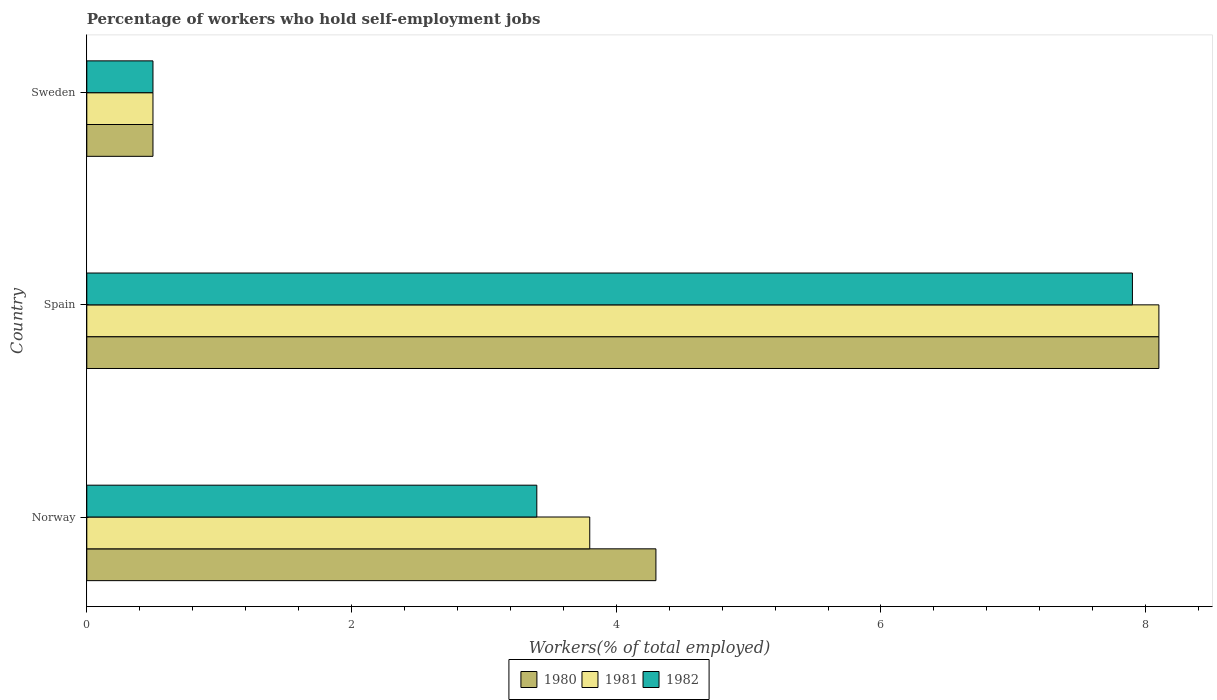How many different coloured bars are there?
Give a very brief answer. 3. How many groups of bars are there?
Your response must be concise. 3. Are the number of bars on each tick of the Y-axis equal?
Your response must be concise. Yes. What is the label of the 1st group of bars from the top?
Provide a succinct answer. Sweden. What is the percentage of self-employed workers in 1982 in Spain?
Your answer should be compact. 7.9. Across all countries, what is the maximum percentage of self-employed workers in 1980?
Provide a short and direct response. 8.1. In which country was the percentage of self-employed workers in 1982 maximum?
Provide a succinct answer. Spain. What is the total percentage of self-employed workers in 1982 in the graph?
Your answer should be compact. 11.8. What is the difference between the percentage of self-employed workers in 1982 in Norway and that in Sweden?
Keep it short and to the point. 2.9. What is the difference between the percentage of self-employed workers in 1981 in Norway and the percentage of self-employed workers in 1982 in Sweden?
Keep it short and to the point. 3.3. What is the average percentage of self-employed workers in 1982 per country?
Your response must be concise. 3.93. What is the ratio of the percentage of self-employed workers in 1981 in Spain to that in Sweden?
Your response must be concise. 16.2. Is the percentage of self-employed workers in 1980 in Spain less than that in Sweden?
Offer a terse response. No. What is the difference between the highest and the second highest percentage of self-employed workers in 1981?
Offer a very short reply. 4.3. What is the difference between the highest and the lowest percentage of self-employed workers in 1981?
Your response must be concise. 7.6. In how many countries, is the percentage of self-employed workers in 1981 greater than the average percentage of self-employed workers in 1981 taken over all countries?
Keep it short and to the point. 1. Is the sum of the percentage of self-employed workers in 1982 in Spain and Sweden greater than the maximum percentage of self-employed workers in 1981 across all countries?
Your response must be concise. Yes. What does the 1st bar from the top in Spain represents?
Provide a short and direct response. 1982. Is it the case that in every country, the sum of the percentage of self-employed workers in 1981 and percentage of self-employed workers in 1982 is greater than the percentage of self-employed workers in 1980?
Your response must be concise. Yes. How many countries are there in the graph?
Give a very brief answer. 3. What is the difference between two consecutive major ticks on the X-axis?
Provide a short and direct response. 2. How many legend labels are there?
Keep it short and to the point. 3. How are the legend labels stacked?
Offer a terse response. Horizontal. What is the title of the graph?
Make the answer very short. Percentage of workers who hold self-employment jobs. What is the label or title of the X-axis?
Keep it short and to the point. Workers(% of total employed). What is the Workers(% of total employed) in 1980 in Norway?
Your answer should be compact. 4.3. What is the Workers(% of total employed) of 1981 in Norway?
Make the answer very short. 3.8. What is the Workers(% of total employed) in 1982 in Norway?
Your answer should be very brief. 3.4. What is the Workers(% of total employed) of 1980 in Spain?
Provide a succinct answer. 8.1. What is the Workers(% of total employed) in 1981 in Spain?
Ensure brevity in your answer.  8.1. What is the Workers(% of total employed) in 1982 in Spain?
Give a very brief answer. 7.9. Across all countries, what is the maximum Workers(% of total employed) in 1980?
Provide a short and direct response. 8.1. Across all countries, what is the maximum Workers(% of total employed) in 1981?
Make the answer very short. 8.1. Across all countries, what is the maximum Workers(% of total employed) of 1982?
Your answer should be compact. 7.9. Across all countries, what is the minimum Workers(% of total employed) of 1980?
Your response must be concise. 0.5. Across all countries, what is the minimum Workers(% of total employed) of 1982?
Your answer should be very brief. 0.5. What is the total Workers(% of total employed) of 1980 in the graph?
Your answer should be compact. 12.9. What is the total Workers(% of total employed) in 1982 in the graph?
Your answer should be very brief. 11.8. What is the difference between the Workers(% of total employed) in 1981 in Norway and that in Spain?
Your answer should be very brief. -4.3. What is the difference between the Workers(% of total employed) of 1982 in Norway and that in Spain?
Give a very brief answer. -4.5. What is the difference between the Workers(% of total employed) of 1980 in Norway and that in Sweden?
Keep it short and to the point. 3.8. What is the difference between the Workers(% of total employed) of 1982 in Spain and that in Sweden?
Your answer should be compact. 7.4. What is the difference between the Workers(% of total employed) in 1980 in Norway and the Workers(% of total employed) in 1982 in Spain?
Offer a very short reply. -3.6. What is the difference between the Workers(% of total employed) of 1980 in Norway and the Workers(% of total employed) of 1981 in Sweden?
Provide a short and direct response. 3.8. What is the difference between the Workers(% of total employed) of 1981 in Norway and the Workers(% of total employed) of 1982 in Sweden?
Make the answer very short. 3.3. What is the difference between the Workers(% of total employed) in 1980 in Spain and the Workers(% of total employed) in 1981 in Sweden?
Your response must be concise. 7.6. What is the average Workers(% of total employed) of 1981 per country?
Offer a terse response. 4.13. What is the average Workers(% of total employed) in 1982 per country?
Offer a very short reply. 3.93. What is the difference between the Workers(% of total employed) of 1980 and Workers(% of total employed) of 1982 in Norway?
Offer a very short reply. 0.9. What is the difference between the Workers(% of total employed) in 1980 and Workers(% of total employed) in 1982 in Spain?
Provide a short and direct response. 0.2. What is the difference between the Workers(% of total employed) in 1981 and Workers(% of total employed) in 1982 in Spain?
Provide a short and direct response. 0.2. What is the difference between the Workers(% of total employed) in 1980 and Workers(% of total employed) in 1981 in Sweden?
Ensure brevity in your answer.  0. What is the difference between the Workers(% of total employed) in 1981 and Workers(% of total employed) in 1982 in Sweden?
Offer a terse response. 0. What is the ratio of the Workers(% of total employed) of 1980 in Norway to that in Spain?
Your answer should be compact. 0.53. What is the ratio of the Workers(% of total employed) of 1981 in Norway to that in Spain?
Offer a terse response. 0.47. What is the ratio of the Workers(% of total employed) of 1982 in Norway to that in Spain?
Ensure brevity in your answer.  0.43. What is the ratio of the Workers(% of total employed) in 1982 in Norway to that in Sweden?
Provide a short and direct response. 6.8. What is the ratio of the Workers(% of total employed) in 1980 in Spain to that in Sweden?
Offer a very short reply. 16.2. What is the ratio of the Workers(% of total employed) of 1981 in Spain to that in Sweden?
Ensure brevity in your answer.  16.2. What is the difference between the highest and the second highest Workers(% of total employed) in 1982?
Provide a succinct answer. 4.5. 